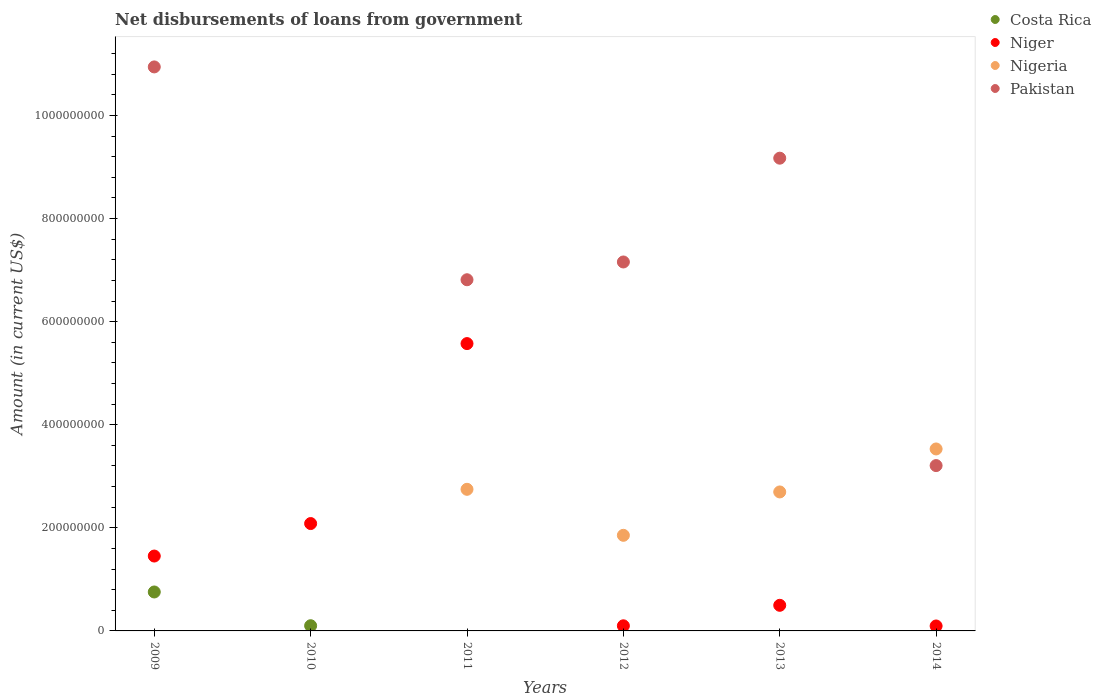How many different coloured dotlines are there?
Give a very brief answer. 4. What is the amount of loan disbursed from government in Pakistan in 2013?
Give a very brief answer. 9.17e+08. Across all years, what is the maximum amount of loan disbursed from government in Niger?
Your response must be concise. 5.57e+08. Across all years, what is the minimum amount of loan disbursed from government in Nigeria?
Offer a terse response. 0. In which year was the amount of loan disbursed from government in Pakistan maximum?
Your answer should be compact. 2009. What is the total amount of loan disbursed from government in Pakistan in the graph?
Make the answer very short. 3.73e+09. What is the difference between the amount of loan disbursed from government in Pakistan in 2009 and that in 2014?
Offer a very short reply. 7.73e+08. What is the average amount of loan disbursed from government in Costa Rica per year?
Give a very brief answer. 1.43e+07. In the year 2012, what is the difference between the amount of loan disbursed from government in Pakistan and amount of loan disbursed from government in Nigeria?
Provide a succinct answer. 5.30e+08. What is the ratio of the amount of loan disbursed from government in Pakistan in 2013 to that in 2014?
Your response must be concise. 2.86. Is the amount of loan disbursed from government in Niger in 2013 less than that in 2014?
Make the answer very short. No. Is the difference between the amount of loan disbursed from government in Pakistan in 2013 and 2014 greater than the difference between the amount of loan disbursed from government in Nigeria in 2013 and 2014?
Provide a succinct answer. Yes. What is the difference between the highest and the second highest amount of loan disbursed from government in Nigeria?
Provide a succinct answer. 7.83e+07. What is the difference between the highest and the lowest amount of loan disbursed from government in Niger?
Offer a very short reply. 5.48e+08. In how many years, is the amount of loan disbursed from government in Pakistan greater than the average amount of loan disbursed from government in Pakistan taken over all years?
Offer a very short reply. 4. Is the sum of the amount of loan disbursed from government in Nigeria in 2013 and 2014 greater than the maximum amount of loan disbursed from government in Niger across all years?
Offer a terse response. Yes. Is it the case that in every year, the sum of the amount of loan disbursed from government in Nigeria and amount of loan disbursed from government in Pakistan  is greater than the amount of loan disbursed from government in Costa Rica?
Give a very brief answer. No. Does the amount of loan disbursed from government in Niger monotonically increase over the years?
Provide a succinct answer. No. How many dotlines are there?
Provide a succinct answer. 4. How many years are there in the graph?
Offer a very short reply. 6. Where does the legend appear in the graph?
Offer a terse response. Top right. How many legend labels are there?
Ensure brevity in your answer.  4. What is the title of the graph?
Offer a terse response. Net disbursements of loans from government. What is the label or title of the Y-axis?
Make the answer very short. Amount (in current US$). What is the Amount (in current US$) of Costa Rica in 2009?
Your response must be concise. 7.56e+07. What is the Amount (in current US$) in Niger in 2009?
Provide a short and direct response. 1.45e+08. What is the Amount (in current US$) in Nigeria in 2009?
Offer a terse response. 0. What is the Amount (in current US$) in Pakistan in 2009?
Your answer should be compact. 1.09e+09. What is the Amount (in current US$) of Costa Rica in 2010?
Your answer should be compact. 1.01e+07. What is the Amount (in current US$) of Niger in 2010?
Your response must be concise. 2.08e+08. What is the Amount (in current US$) of Nigeria in 2010?
Make the answer very short. 0. What is the Amount (in current US$) of Costa Rica in 2011?
Keep it short and to the point. 0. What is the Amount (in current US$) of Niger in 2011?
Your answer should be compact. 5.57e+08. What is the Amount (in current US$) in Nigeria in 2011?
Provide a succinct answer. 2.75e+08. What is the Amount (in current US$) of Pakistan in 2011?
Ensure brevity in your answer.  6.81e+08. What is the Amount (in current US$) of Niger in 2012?
Your answer should be very brief. 9.92e+06. What is the Amount (in current US$) in Nigeria in 2012?
Your answer should be very brief. 1.85e+08. What is the Amount (in current US$) of Pakistan in 2012?
Your response must be concise. 7.16e+08. What is the Amount (in current US$) of Niger in 2013?
Keep it short and to the point. 4.97e+07. What is the Amount (in current US$) in Nigeria in 2013?
Provide a short and direct response. 2.70e+08. What is the Amount (in current US$) of Pakistan in 2013?
Provide a succinct answer. 9.17e+08. What is the Amount (in current US$) in Costa Rica in 2014?
Your answer should be compact. 0. What is the Amount (in current US$) of Niger in 2014?
Your response must be concise. 9.59e+06. What is the Amount (in current US$) of Nigeria in 2014?
Your response must be concise. 3.53e+08. What is the Amount (in current US$) in Pakistan in 2014?
Make the answer very short. 3.21e+08. Across all years, what is the maximum Amount (in current US$) of Costa Rica?
Provide a short and direct response. 7.56e+07. Across all years, what is the maximum Amount (in current US$) of Niger?
Give a very brief answer. 5.57e+08. Across all years, what is the maximum Amount (in current US$) in Nigeria?
Ensure brevity in your answer.  3.53e+08. Across all years, what is the maximum Amount (in current US$) in Pakistan?
Provide a short and direct response. 1.09e+09. Across all years, what is the minimum Amount (in current US$) of Costa Rica?
Your response must be concise. 0. Across all years, what is the minimum Amount (in current US$) in Niger?
Your answer should be compact. 9.59e+06. What is the total Amount (in current US$) of Costa Rica in the graph?
Your answer should be very brief. 8.56e+07. What is the total Amount (in current US$) in Niger in the graph?
Your answer should be compact. 9.80e+08. What is the total Amount (in current US$) in Nigeria in the graph?
Make the answer very short. 1.08e+09. What is the total Amount (in current US$) in Pakistan in the graph?
Provide a short and direct response. 3.73e+09. What is the difference between the Amount (in current US$) of Costa Rica in 2009 and that in 2010?
Keep it short and to the point. 6.55e+07. What is the difference between the Amount (in current US$) of Niger in 2009 and that in 2010?
Make the answer very short. -6.30e+07. What is the difference between the Amount (in current US$) of Niger in 2009 and that in 2011?
Provide a short and direct response. -4.12e+08. What is the difference between the Amount (in current US$) in Pakistan in 2009 and that in 2011?
Provide a succinct answer. 4.13e+08. What is the difference between the Amount (in current US$) of Niger in 2009 and that in 2012?
Your answer should be compact. 1.35e+08. What is the difference between the Amount (in current US$) in Pakistan in 2009 and that in 2012?
Ensure brevity in your answer.  3.78e+08. What is the difference between the Amount (in current US$) in Niger in 2009 and that in 2013?
Keep it short and to the point. 9.56e+07. What is the difference between the Amount (in current US$) in Pakistan in 2009 and that in 2013?
Your response must be concise. 1.77e+08. What is the difference between the Amount (in current US$) of Niger in 2009 and that in 2014?
Give a very brief answer. 1.36e+08. What is the difference between the Amount (in current US$) of Pakistan in 2009 and that in 2014?
Your answer should be compact. 7.73e+08. What is the difference between the Amount (in current US$) of Niger in 2010 and that in 2011?
Give a very brief answer. -3.49e+08. What is the difference between the Amount (in current US$) of Niger in 2010 and that in 2012?
Offer a terse response. 1.98e+08. What is the difference between the Amount (in current US$) of Niger in 2010 and that in 2013?
Provide a succinct answer. 1.59e+08. What is the difference between the Amount (in current US$) in Niger in 2010 and that in 2014?
Your answer should be very brief. 1.99e+08. What is the difference between the Amount (in current US$) of Niger in 2011 and that in 2012?
Your response must be concise. 5.48e+08. What is the difference between the Amount (in current US$) in Nigeria in 2011 and that in 2012?
Make the answer very short. 8.93e+07. What is the difference between the Amount (in current US$) of Pakistan in 2011 and that in 2012?
Keep it short and to the point. -3.45e+07. What is the difference between the Amount (in current US$) of Niger in 2011 and that in 2013?
Keep it short and to the point. 5.08e+08. What is the difference between the Amount (in current US$) of Nigeria in 2011 and that in 2013?
Make the answer very short. 5.11e+06. What is the difference between the Amount (in current US$) of Pakistan in 2011 and that in 2013?
Offer a terse response. -2.36e+08. What is the difference between the Amount (in current US$) in Niger in 2011 and that in 2014?
Keep it short and to the point. 5.48e+08. What is the difference between the Amount (in current US$) of Nigeria in 2011 and that in 2014?
Ensure brevity in your answer.  -7.83e+07. What is the difference between the Amount (in current US$) in Pakistan in 2011 and that in 2014?
Provide a short and direct response. 3.61e+08. What is the difference between the Amount (in current US$) of Niger in 2012 and that in 2013?
Offer a terse response. -3.98e+07. What is the difference between the Amount (in current US$) of Nigeria in 2012 and that in 2013?
Your answer should be very brief. -8.41e+07. What is the difference between the Amount (in current US$) of Pakistan in 2012 and that in 2013?
Make the answer very short. -2.01e+08. What is the difference between the Amount (in current US$) in Niger in 2012 and that in 2014?
Your response must be concise. 3.30e+05. What is the difference between the Amount (in current US$) of Nigeria in 2012 and that in 2014?
Ensure brevity in your answer.  -1.68e+08. What is the difference between the Amount (in current US$) in Pakistan in 2012 and that in 2014?
Provide a short and direct response. 3.95e+08. What is the difference between the Amount (in current US$) of Niger in 2013 and that in 2014?
Offer a very short reply. 4.01e+07. What is the difference between the Amount (in current US$) of Nigeria in 2013 and that in 2014?
Your answer should be compact. -8.34e+07. What is the difference between the Amount (in current US$) of Pakistan in 2013 and that in 2014?
Provide a short and direct response. 5.96e+08. What is the difference between the Amount (in current US$) of Costa Rica in 2009 and the Amount (in current US$) of Niger in 2010?
Give a very brief answer. -1.33e+08. What is the difference between the Amount (in current US$) in Costa Rica in 2009 and the Amount (in current US$) in Niger in 2011?
Make the answer very short. -4.82e+08. What is the difference between the Amount (in current US$) of Costa Rica in 2009 and the Amount (in current US$) of Nigeria in 2011?
Ensure brevity in your answer.  -1.99e+08. What is the difference between the Amount (in current US$) of Costa Rica in 2009 and the Amount (in current US$) of Pakistan in 2011?
Your answer should be compact. -6.06e+08. What is the difference between the Amount (in current US$) in Niger in 2009 and the Amount (in current US$) in Nigeria in 2011?
Your answer should be compact. -1.29e+08. What is the difference between the Amount (in current US$) in Niger in 2009 and the Amount (in current US$) in Pakistan in 2011?
Give a very brief answer. -5.36e+08. What is the difference between the Amount (in current US$) of Costa Rica in 2009 and the Amount (in current US$) of Niger in 2012?
Your answer should be very brief. 6.56e+07. What is the difference between the Amount (in current US$) in Costa Rica in 2009 and the Amount (in current US$) in Nigeria in 2012?
Your response must be concise. -1.10e+08. What is the difference between the Amount (in current US$) of Costa Rica in 2009 and the Amount (in current US$) of Pakistan in 2012?
Your answer should be compact. -6.40e+08. What is the difference between the Amount (in current US$) of Niger in 2009 and the Amount (in current US$) of Nigeria in 2012?
Your response must be concise. -4.02e+07. What is the difference between the Amount (in current US$) in Niger in 2009 and the Amount (in current US$) in Pakistan in 2012?
Your answer should be compact. -5.70e+08. What is the difference between the Amount (in current US$) of Costa Rica in 2009 and the Amount (in current US$) of Niger in 2013?
Your answer should be compact. 2.59e+07. What is the difference between the Amount (in current US$) of Costa Rica in 2009 and the Amount (in current US$) of Nigeria in 2013?
Offer a very short reply. -1.94e+08. What is the difference between the Amount (in current US$) in Costa Rica in 2009 and the Amount (in current US$) in Pakistan in 2013?
Make the answer very short. -8.42e+08. What is the difference between the Amount (in current US$) in Niger in 2009 and the Amount (in current US$) in Nigeria in 2013?
Ensure brevity in your answer.  -1.24e+08. What is the difference between the Amount (in current US$) in Niger in 2009 and the Amount (in current US$) in Pakistan in 2013?
Offer a terse response. -7.72e+08. What is the difference between the Amount (in current US$) of Costa Rica in 2009 and the Amount (in current US$) of Niger in 2014?
Offer a very short reply. 6.60e+07. What is the difference between the Amount (in current US$) of Costa Rica in 2009 and the Amount (in current US$) of Nigeria in 2014?
Provide a succinct answer. -2.77e+08. What is the difference between the Amount (in current US$) in Costa Rica in 2009 and the Amount (in current US$) in Pakistan in 2014?
Offer a very short reply. -2.45e+08. What is the difference between the Amount (in current US$) of Niger in 2009 and the Amount (in current US$) of Nigeria in 2014?
Your answer should be very brief. -2.08e+08. What is the difference between the Amount (in current US$) in Niger in 2009 and the Amount (in current US$) in Pakistan in 2014?
Your response must be concise. -1.76e+08. What is the difference between the Amount (in current US$) of Costa Rica in 2010 and the Amount (in current US$) of Niger in 2011?
Provide a short and direct response. -5.47e+08. What is the difference between the Amount (in current US$) of Costa Rica in 2010 and the Amount (in current US$) of Nigeria in 2011?
Keep it short and to the point. -2.65e+08. What is the difference between the Amount (in current US$) in Costa Rica in 2010 and the Amount (in current US$) in Pakistan in 2011?
Keep it short and to the point. -6.71e+08. What is the difference between the Amount (in current US$) in Niger in 2010 and the Amount (in current US$) in Nigeria in 2011?
Ensure brevity in your answer.  -6.64e+07. What is the difference between the Amount (in current US$) of Niger in 2010 and the Amount (in current US$) of Pakistan in 2011?
Give a very brief answer. -4.73e+08. What is the difference between the Amount (in current US$) of Costa Rica in 2010 and the Amount (in current US$) of Niger in 2012?
Keep it short and to the point. 1.71e+05. What is the difference between the Amount (in current US$) of Costa Rica in 2010 and the Amount (in current US$) of Nigeria in 2012?
Your answer should be compact. -1.75e+08. What is the difference between the Amount (in current US$) of Costa Rica in 2010 and the Amount (in current US$) of Pakistan in 2012?
Make the answer very short. -7.06e+08. What is the difference between the Amount (in current US$) of Niger in 2010 and the Amount (in current US$) of Nigeria in 2012?
Your answer should be compact. 2.28e+07. What is the difference between the Amount (in current US$) of Niger in 2010 and the Amount (in current US$) of Pakistan in 2012?
Your response must be concise. -5.07e+08. What is the difference between the Amount (in current US$) in Costa Rica in 2010 and the Amount (in current US$) in Niger in 2013?
Offer a terse response. -3.96e+07. What is the difference between the Amount (in current US$) of Costa Rica in 2010 and the Amount (in current US$) of Nigeria in 2013?
Provide a short and direct response. -2.60e+08. What is the difference between the Amount (in current US$) of Costa Rica in 2010 and the Amount (in current US$) of Pakistan in 2013?
Your response must be concise. -9.07e+08. What is the difference between the Amount (in current US$) in Niger in 2010 and the Amount (in current US$) in Nigeria in 2013?
Give a very brief answer. -6.13e+07. What is the difference between the Amount (in current US$) in Niger in 2010 and the Amount (in current US$) in Pakistan in 2013?
Provide a short and direct response. -7.09e+08. What is the difference between the Amount (in current US$) of Costa Rica in 2010 and the Amount (in current US$) of Niger in 2014?
Your response must be concise. 5.01e+05. What is the difference between the Amount (in current US$) in Costa Rica in 2010 and the Amount (in current US$) in Nigeria in 2014?
Make the answer very short. -3.43e+08. What is the difference between the Amount (in current US$) in Costa Rica in 2010 and the Amount (in current US$) in Pakistan in 2014?
Ensure brevity in your answer.  -3.11e+08. What is the difference between the Amount (in current US$) of Niger in 2010 and the Amount (in current US$) of Nigeria in 2014?
Your answer should be very brief. -1.45e+08. What is the difference between the Amount (in current US$) in Niger in 2010 and the Amount (in current US$) in Pakistan in 2014?
Make the answer very short. -1.12e+08. What is the difference between the Amount (in current US$) of Niger in 2011 and the Amount (in current US$) of Nigeria in 2012?
Your answer should be very brief. 3.72e+08. What is the difference between the Amount (in current US$) of Niger in 2011 and the Amount (in current US$) of Pakistan in 2012?
Offer a terse response. -1.58e+08. What is the difference between the Amount (in current US$) of Nigeria in 2011 and the Amount (in current US$) of Pakistan in 2012?
Your answer should be very brief. -4.41e+08. What is the difference between the Amount (in current US$) of Niger in 2011 and the Amount (in current US$) of Nigeria in 2013?
Provide a short and direct response. 2.88e+08. What is the difference between the Amount (in current US$) of Niger in 2011 and the Amount (in current US$) of Pakistan in 2013?
Offer a terse response. -3.60e+08. What is the difference between the Amount (in current US$) in Nigeria in 2011 and the Amount (in current US$) in Pakistan in 2013?
Offer a very short reply. -6.42e+08. What is the difference between the Amount (in current US$) in Niger in 2011 and the Amount (in current US$) in Nigeria in 2014?
Give a very brief answer. 2.04e+08. What is the difference between the Amount (in current US$) in Niger in 2011 and the Amount (in current US$) in Pakistan in 2014?
Ensure brevity in your answer.  2.37e+08. What is the difference between the Amount (in current US$) in Nigeria in 2011 and the Amount (in current US$) in Pakistan in 2014?
Give a very brief answer. -4.60e+07. What is the difference between the Amount (in current US$) in Niger in 2012 and the Amount (in current US$) in Nigeria in 2013?
Provide a succinct answer. -2.60e+08. What is the difference between the Amount (in current US$) in Niger in 2012 and the Amount (in current US$) in Pakistan in 2013?
Your answer should be compact. -9.07e+08. What is the difference between the Amount (in current US$) of Nigeria in 2012 and the Amount (in current US$) of Pakistan in 2013?
Keep it short and to the point. -7.32e+08. What is the difference between the Amount (in current US$) in Niger in 2012 and the Amount (in current US$) in Nigeria in 2014?
Make the answer very short. -3.43e+08. What is the difference between the Amount (in current US$) of Niger in 2012 and the Amount (in current US$) of Pakistan in 2014?
Provide a short and direct response. -3.11e+08. What is the difference between the Amount (in current US$) of Nigeria in 2012 and the Amount (in current US$) of Pakistan in 2014?
Provide a succinct answer. -1.35e+08. What is the difference between the Amount (in current US$) in Niger in 2013 and the Amount (in current US$) in Nigeria in 2014?
Offer a terse response. -3.03e+08. What is the difference between the Amount (in current US$) of Niger in 2013 and the Amount (in current US$) of Pakistan in 2014?
Your response must be concise. -2.71e+08. What is the difference between the Amount (in current US$) of Nigeria in 2013 and the Amount (in current US$) of Pakistan in 2014?
Offer a very short reply. -5.11e+07. What is the average Amount (in current US$) of Costa Rica per year?
Provide a short and direct response. 1.43e+07. What is the average Amount (in current US$) of Niger per year?
Provide a succinct answer. 1.63e+08. What is the average Amount (in current US$) of Nigeria per year?
Offer a very short reply. 1.80e+08. What is the average Amount (in current US$) in Pakistan per year?
Your answer should be compact. 6.22e+08. In the year 2009, what is the difference between the Amount (in current US$) of Costa Rica and Amount (in current US$) of Niger?
Offer a terse response. -6.97e+07. In the year 2009, what is the difference between the Amount (in current US$) of Costa Rica and Amount (in current US$) of Pakistan?
Make the answer very short. -1.02e+09. In the year 2009, what is the difference between the Amount (in current US$) in Niger and Amount (in current US$) in Pakistan?
Your answer should be compact. -9.49e+08. In the year 2010, what is the difference between the Amount (in current US$) in Costa Rica and Amount (in current US$) in Niger?
Ensure brevity in your answer.  -1.98e+08. In the year 2011, what is the difference between the Amount (in current US$) in Niger and Amount (in current US$) in Nigeria?
Offer a very short reply. 2.83e+08. In the year 2011, what is the difference between the Amount (in current US$) of Niger and Amount (in current US$) of Pakistan?
Your answer should be compact. -1.24e+08. In the year 2011, what is the difference between the Amount (in current US$) of Nigeria and Amount (in current US$) of Pakistan?
Offer a very short reply. -4.07e+08. In the year 2012, what is the difference between the Amount (in current US$) of Niger and Amount (in current US$) of Nigeria?
Provide a short and direct response. -1.76e+08. In the year 2012, what is the difference between the Amount (in current US$) of Niger and Amount (in current US$) of Pakistan?
Your response must be concise. -7.06e+08. In the year 2012, what is the difference between the Amount (in current US$) of Nigeria and Amount (in current US$) of Pakistan?
Keep it short and to the point. -5.30e+08. In the year 2013, what is the difference between the Amount (in current US$) of Niger and Amount (in current US$) of Nigeria?
Your response must be concise. -2.20e+08. In the year 2013, what is the difference between the Amount (in current US$) of Niger and Amount (in current US$) of Pakistan?
Offer a very short reply. -8.67e+08. In the year 2013, what is the difference between the Amount (in current US$) in Nigeria and Amount (in current US$) in Pakistan?
Provide a succinct answer. -6.48e+08. In the year 2014, what is the difference between the Amount (in current US$) of Niger and Amount (in current US$) of Nigeria?
Your response must be concise. -3.43e+08. In the year 2014, what is the difference between the Amount (in current US$) in Niger and Amount (in current US$) in Pakistan?
Your response must be concise. -3.11e+08. In the year 2014, what is the difference between the Amount (in current US$) of Nigeria and Amount (in current US$) of Pakistan?
Give a very brief answer. 3.23e+07. What is the ratio of the Amount (in current US$) in Costa Rica in 2009 to that in 2010?
Your answer should be compact. 7.49. What is the ratio of the Amount (in current US$) in Niger in 2009 to that in 2010?
Keep it short and to the point. 0.7. What is the ratio of the Amount (in current US$) in Niger in 2009 to that in 2011?
Offer a terse response. 0.26. What is the ratio of the Amount (in current US$) of Pakistan in 2009 to that in 2011?
Your answer should be compact. 1.61. What is the ratio of the Amount (in current US$) in Niger in 2009 to that in 2012?
Provide a short and direct response. 14.65. What is the ratio of the Amount (in current US$) of Pakistan in 2009 to that in 2012?
Offer a terse response. 1.53. What is the ratio of the Amount (in current US$) of Niger in 2009 to that in 2013?
Give a very brief answer. 2.92. What is the ratio of the Amount (in current US$) in Pakistan in 2009 to that in 2013?
Your answer should be very brief. 1.19. What is the ratio of the Amount (in current US$) of Niger in 2009 to that in 2014?
Make the answer very short. 15.15. What is the ratio of the Amount (in current US$) in Pakistan in 2009 to that in 2014?
Provide a succinct answer. 3.41. What is the ratio of the Amount (in current US$) of Niger in 2010 to that in 2011?
Provide a succinct answer. 0.37. What is the ratio of the Amount (in current US$) of Niger in 2010 to that in 2012?
Offer a terse response. 21. What is the ratio of the Amount (in current US$) of Niger in 2010 to that in 2013?
Keep it short and to the point. 4.19. What is the ratio of the Amount (in current US$) of Niger in 2010 to that in 2014?
Ensure brevity in your answer.  21.73. What is the ratio of the Amount (in current US$) of Niger in 2011 to that in 2012?
Your response must be concise. 56.21. What is the ratio of the Amount (in current US$) in Nigeria in 2011 to that in 2012?
Ensure brevity in your answer.  1.48. What is the ratio of the Amount (in current US$) of Pakistan in 2011 to that in 2012?
Provide a short and direct response. 0.95. What is the ratio of the Amount (in current US$) in Niger in 2011 to that in 2013?
Keep it short and to the point. 11.22. What is the ratio of the Amount (in current US$) of Nigeria in 2011 to that in 2013?
Offer a very short reply. 1.02. What is the ratio of the Amount (in current US$) in Pakistan in 2011 to that in 2013?
Offer a terse response. 0.74. What is the ratio of the Amount (in current US$) of Niger in 2011 to that in 2014?
Provide a short and direct response. 58.14. What is the ratio of the Amount (in current US$) in Nigeria in 2011 to that in 2014?
Your response must be concise. 0.78. What is the ratio of the Amount (in current US$) in Pakistan in 2011 to that in 2014?
Give a very brief answer. 2.12. What is the ratio of the Amount (in current US$) in Niger in 2012 to that in 2013?
Keep it short and to the point. 0.2. What is the ratio of the Amount (in current US$) in Nigeria in 2012 to that in 2013?
Offer a very short reply. 0.69. What is the ratio of the Amount (in current US$) in Pakistan in 2012 to that in 2013?
Offer a very short reply. 0.78. What is the ratio of the Amount (in current US$) of Niger in 2012 to that in 2014?
Offer a terse response. 1.03. What is the ratio of the Amount (in current US$) of Nigeria in 2012 to that in 2014?
Provide a succinct answer. 0.53. What is the ratio of the Amount (in current US$) of Pakistan in 2012 to that in 2014?
Offer a terse response. 2.23. What is the ratio of the Amount (in current US$) of Niger in 2013 to that in 2014?
Offer a very short reply. 5.18. What is the ratio of the Amount (in current US$) of Nigeria in 2013 to that in 2014?
Offer a terse response. 0.76. What is the ratio of the Amount (in current US$) in Pakistan in 2013 to that in 2014?
Your answer should be compact. 2.86. What is the difference between the highest and the second highest Amount (in current US$) in Niger?
Make the answer very short. 3.49e+08. What is the difference between the highest and the second highest Amount (in current US$) in Nigeria?
Offer a very short reply. 7.83e+07. What is the difference between the highest and the second highest Amount (in current US$) in Pakistan?
Provide a succinct answer. 1.77e+08. What is the difference between the highest and the lowest Amount (in current US$) in Costa Rica?
Your answer should be compact. 7.56e+07. What is the difference between the highest and the lowest Amount (in current US$) of Niger?
Ensure brevity in your answer.  5.48e+08. What is the difference between the highest and the lowest Amount (in current US$) of Nigeria?
Make the answer very short. 3.53e+08. What is the difference between the highest and the lowest Amount (in current US$) in Pakistan?
Give a very brief answer. 1.09e+09. 